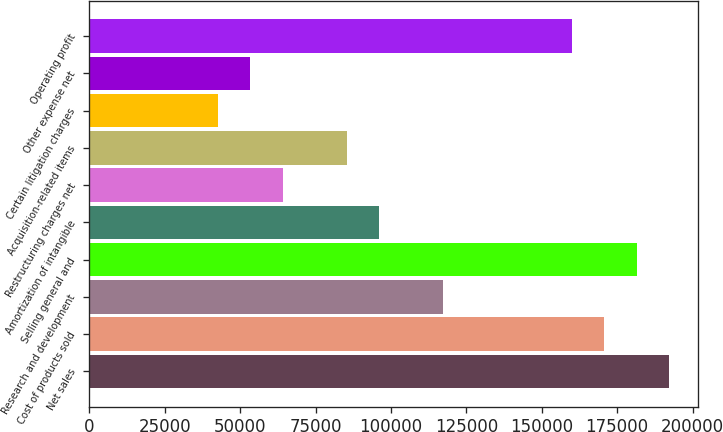Convert chart. <chart><loc_0><loc_0><loc_500><loc_500><bar_chart><fcel>Net sales<fcel>Cost of products sold<fcel>Research and development<fcel>Selling general and<fcel>Amortization of intangible<fcel>Restructuring charges net<fcel>Acquisition-related items<fcel>Certain litigation charges<fcel>Other expense net<fcel>Operating profit<nl><fcel>192106<fcel>170761<fcel>117398<fcel>181433<fcel>96053.5<fcel>64036.1<fcel>85381.1<fcel>42691.1<fcel>53363.6<fcel>160088<nl></chart> 